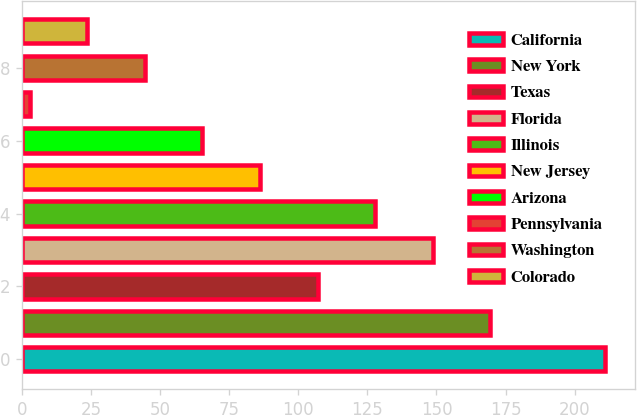<chart> <loc_0><loc_0><loc_500><loc_500><bar_chart><fcel>California<fcel>New York<fcel>Texas<fcel>Florida<fcel>Illinois<fcel>New Jersey<fcel>Arizona<fcel>Pennsylvania<fcel>Washington<fcel>Colorado<nl><fcel>211.1<fcel>169.46<fcel>107<fcel>148.64<fcel>127.82<fcel>86.18<fcel>65.36<fcel>2.9<fcel>44.54<fcel>23.72<nl></chart> 